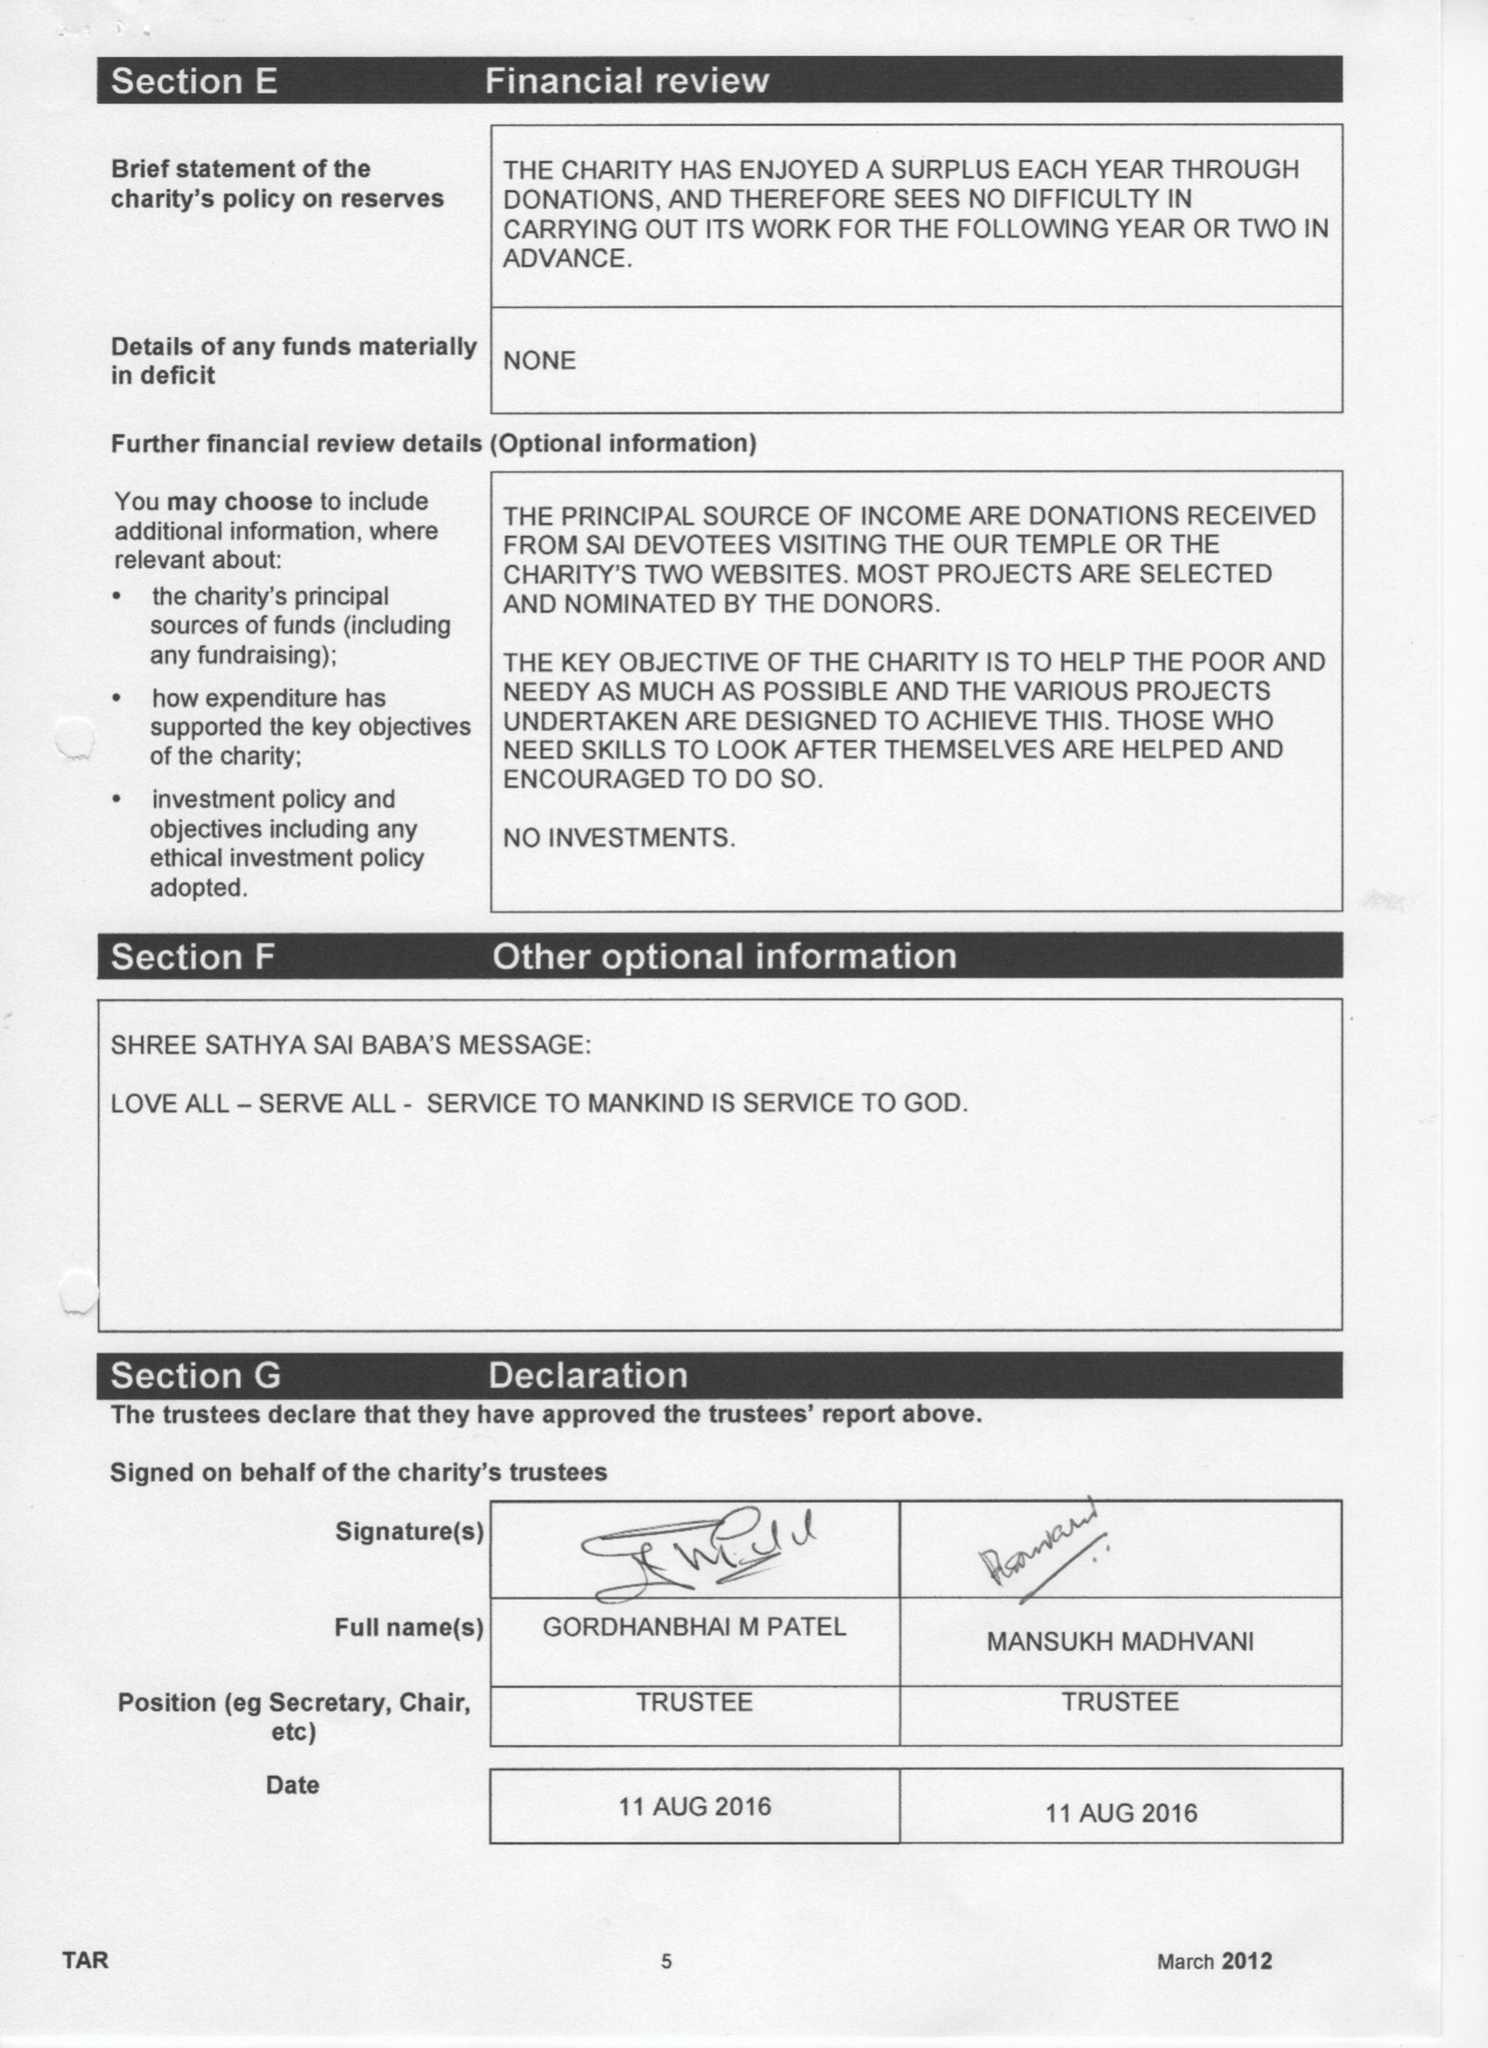What is the value for the income_annually_in_british_pounds?
Answer the question using a single word or phrase. 104599.00 